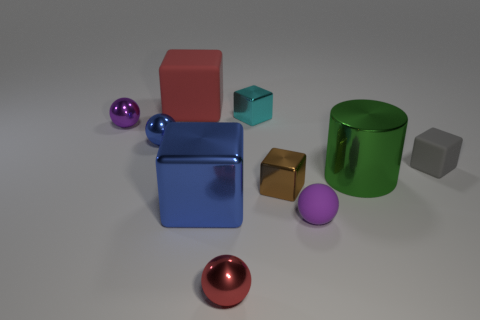There is a blue block; are there any small matte blocks to the right of it?
Keep it short and to the point. Yes. What size is the cyan object that is the same shape as the gray rubber object?
Make the answer very short. Small. Is the color of the small rubber ball the same as the thing left of the blue metallic sphere?
Provide a short and direct response. Yes. Is the number of gray balls less than the number of big blocks?
Provide a succinct answer. Yes. How many other objects are there of the same color as the big matte object?
Ensure brevity in your answer.  1. How many tiny blue blocks are there?
Keep it short and to the point. 0. Is the number of tiny shiny things that are to the right of the big green cylinder less than the number of tiny yellow cylinders?
Keep it short and to the point. No. Does the sphere in front of the small purple rubber object have the same material as the large green cylinder?
Give a very brief answer. Yes. The tiny purple thing that is to the right of the red object that is behind the tiny purple sphere that is left of the big rubber block is what shape?
Keep it short and to the point. Sphere. Are there any green shiny cylinders that have the same size as the blue shiny cube?
Give a very brief answer. Yes. 